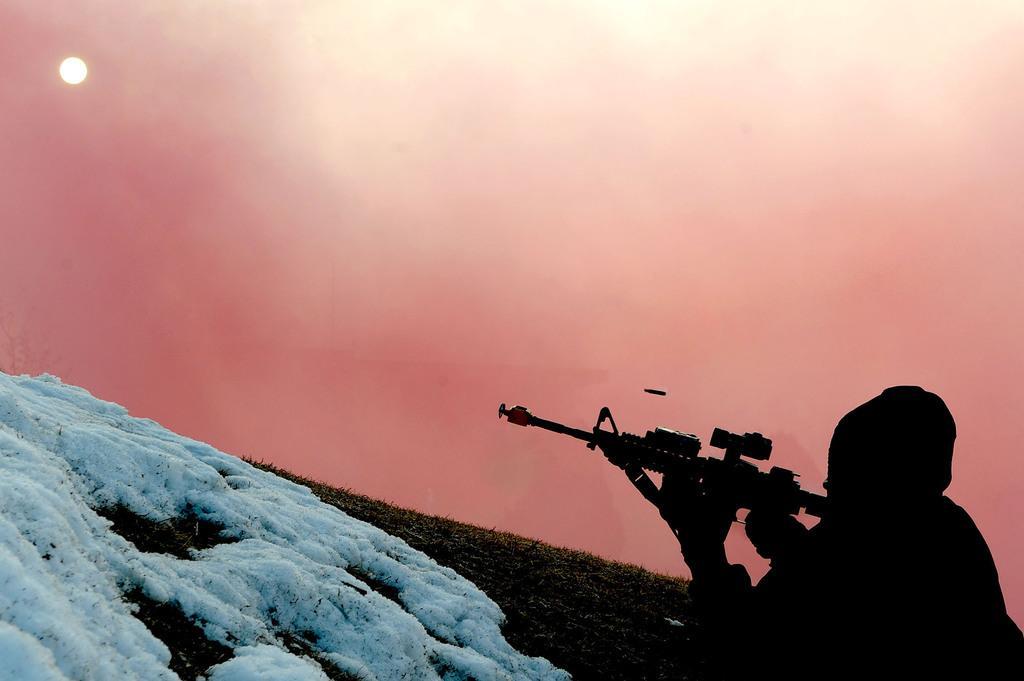In one or two sentences, can you explain what this image depicts? In this image I can see the ground, some snow on the ground and a person is lying on the ground holding a weapon. In the background I can see the sky and the moon. 